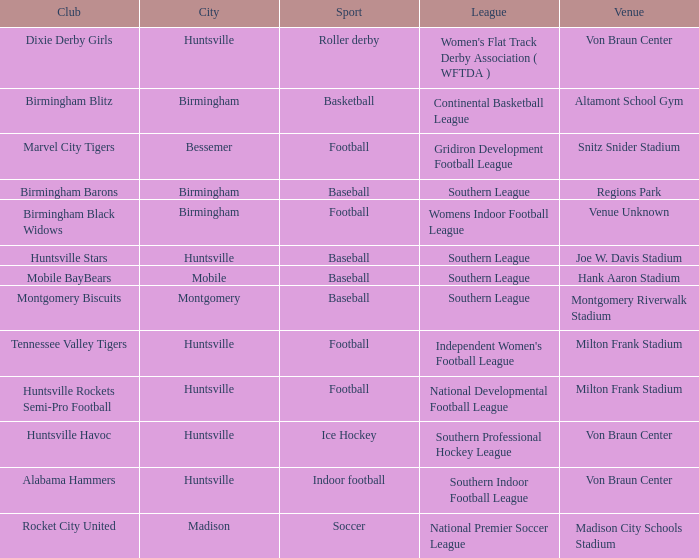Would you be able to parse every entry in this table? {'header': ['Club', 'City', 'Sport', 'League', 'Venue'], 'rows': [['Dixie Derby Girls', 'Huntsville', 'Roller derby', "Women's Flat Track Derby Association ( WFTDA )", 'Von Braun Center'], ['Birmingham Blitz', 'Birmingham', 'Basketball', 'Continental Basketball League', 'Altamont School Gym'], ['Marvel City Tigers', 'Bessemer', 'Football', 'Gridiron Development Football League', 'Snitz Snider Stadium'], ['Birmingham Barons', 'Birmingham', 'Baseball', 'Southern League', 'Regions Park'], ['Birmingham Black Widows', 'Birmingham', 'Football', 'Womens Indoor Football League', 'Venue Unknown'], ['Huntsville Stars', 'Huntsville', 'Baseball', 'Southern League', 'Joe W. Davis Stadium'], ['Mobile BayBears', 'Mobile', 'Baseball', 'Southern League', 'Hank Aaron Stadium'], ['Montgomery Biscuits', 'Montgomery', 'Baseball', 'Southern League', 'Montgomery Riverwalk Stadium'], ['Tennessee Valley Tigers', 'Huntsville', 'Football', "Independent Women's Football League", 'Milton Frank Stadium'], ['Huntsville Rockets Semi-Pro Football', 'Huntsville', 'Football', 'National Developmental Football League', 'Milton Frank Stadium'], ['Huntsville Havoc', 'Huntsville', 'Ice Hockey', 'Southern Professional Hockey League', 'Von Braun Center'], ['Alabama Hammers', 'Huntsville', 'Indoor football', 'Southern Indoor Football League', 'Von Braun Center'], ['Rocket City United', 'Madison', 'Soccer', 'National Premier Soccer League', 'Madison City Schools Stadium']]} Which venue held a basketball team? Altamont School Gym. 